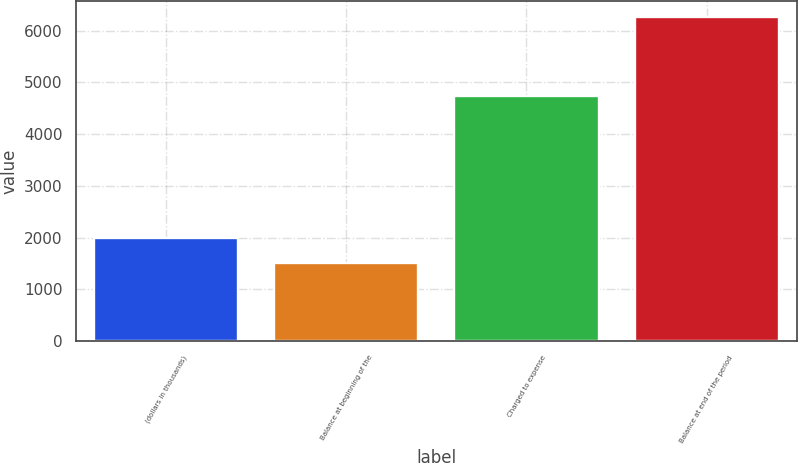Convert chart to OTSL. <chart><loc_0><loc_0><loc_500><loc_500><bar_chart><fcel>(dollars in thousands)<fcel>Balance at beginning of the<fcel>Charged to expense<fcel>Balance at end of the period<nl><fcel>2003<fcel>1510<fcel>4745<fcel>6255<nl></chart> 